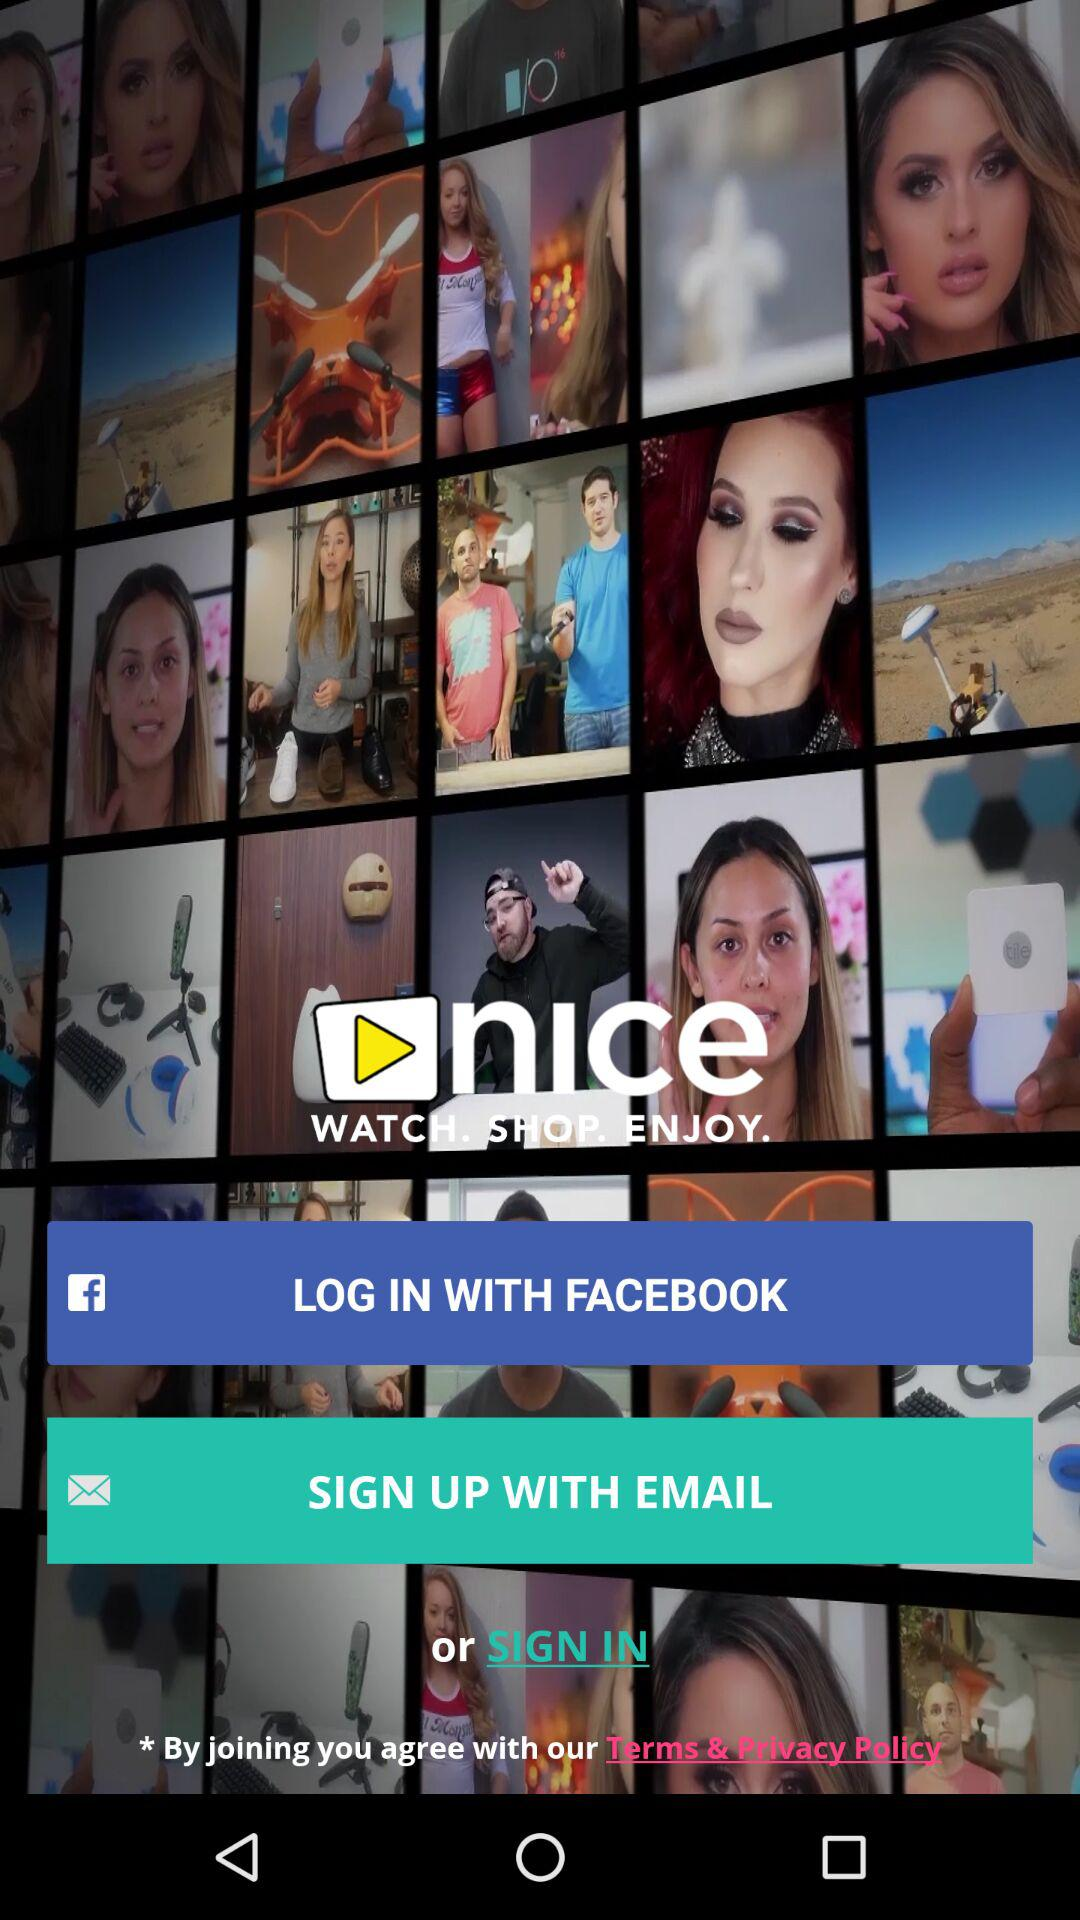What is the application name? The application name is "nice". 